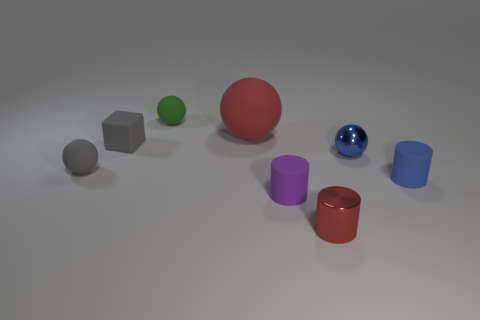Taking a look at the colors, how would you describe the overall color palette used in this image? The color palette in this image is quite varied, featuring bold primary and secondary colors. The reds, blues, and greens are deep and vibrant, while the gray adds a neutral balance. The matte and metallic finishes of the objects provide contrast not just in texture, but in how they reflect and absorb light, affecting the perception of their colors. 